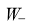Convert formula to latex. <formula><loc_0><loc_0><loc_500><loc_500>W _ { - }</formula> 